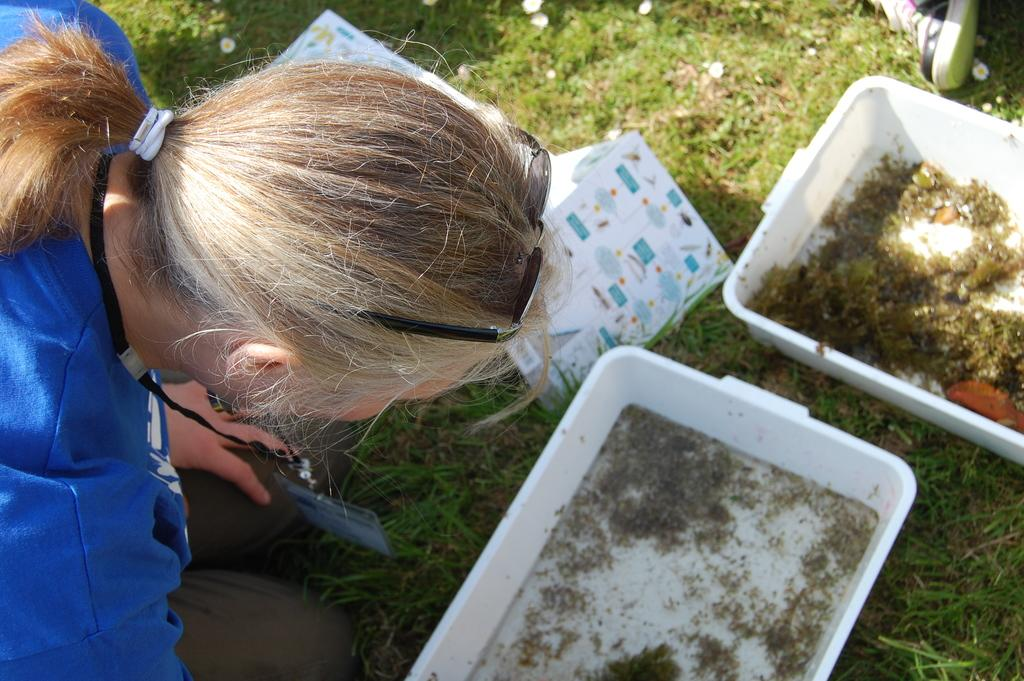Who is present in the image? There is a person in the image. What is the person wearing? The person is wearing a blue shirt and brown pants. How many trays are visible in the image? There are two trays in white color in the image. What color is the grass in the image? The grass in the image is green. What is the person's reaction of disgust towards the trays in the image? There is no indication of the person's reaction or emotion in the image, so it cannot be determined if they feel disgust towards the trays. How many legs does the person have in the image? The person has two legs, as is typical for humans. 